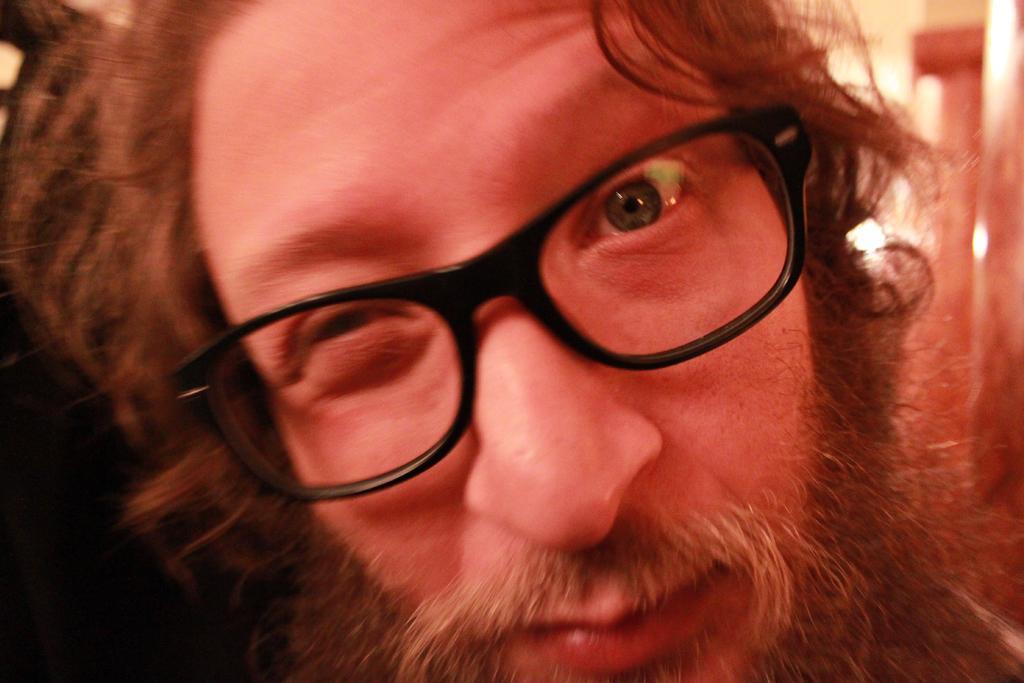In one or two sentences, can you explain what this image depicts? In the center of the image, we can see a person wearing glasses and in the background, there is a wall. 